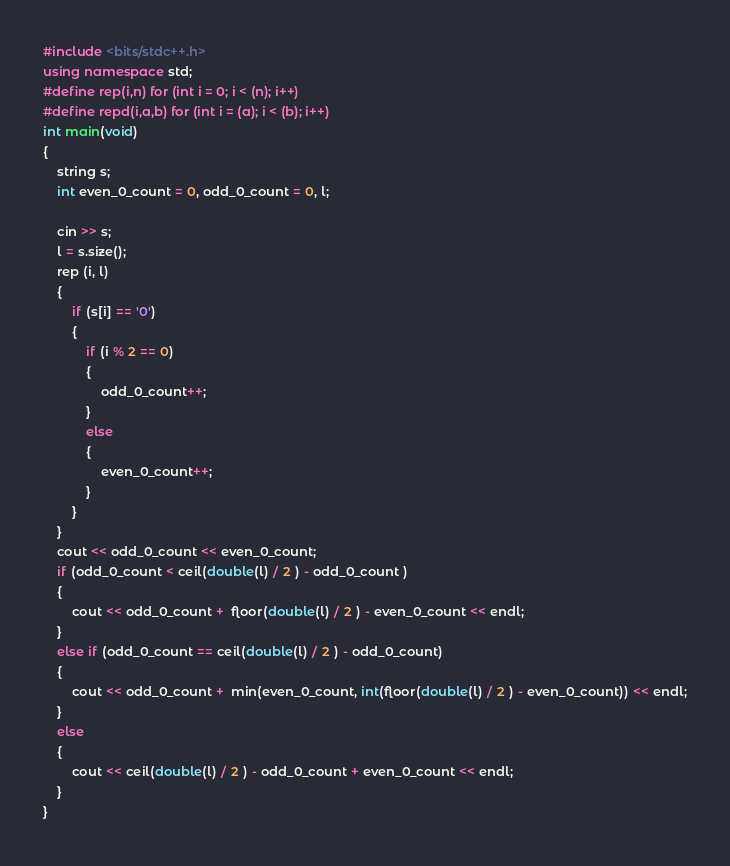<code> <loc_0><loc_0><loc_500><loc_500><_C++_>#include <bits/stdc++.h>
using namespace std;
#define rep(i,n) for (int i = 0; i < (n); i++)
#define repd(i,a,b) for (int i = (a); i < (b); i++)
int main(void)
{
    string s;
    int even_0_count = 0, odd_0_count = 0, l; 
    
    cin >> s;
    l = s.size();
    rep (i, l)
    {
        if (s[i] == '0')
        {
            if (i % 2 == 0)
            {
                odd_0_count++;
            }
            else
            {
                even_0_count++;
            }
        }
    }
    cout << odd_0_count << even_0_count;
    if (odd_0_count < ceil(double(l) / 2 ) - odd_0_count )
    {
        cout << odd_0_count +  floor(double(l) / 2 ) - even_0_count << endl;
    }
    else if (odd_0_count == ceil(double(l) / 2 ) - odd_0_count)
    {
        cout << odd_0_count +  min(even_0_count, int(floor(double(l) / 2 ) - even_0_count)) << endl;
    }
    else
    {
        cout << ceil(double(l) / 2 ) - odd_0_count + even_0_count << endl;
    }
}
</code> 